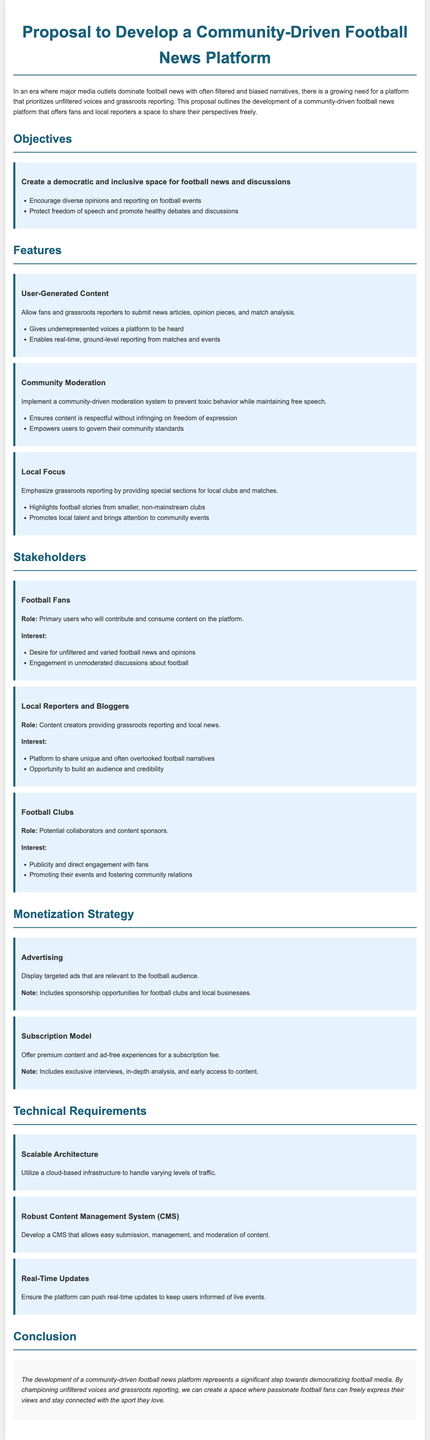What is the title of the proposal? The title is clearly stated at the beginning of the document.
Answer: Proposal to Develop a Community-Driven Football News Platform What is the primary role of football fans in this platform? The section on stakeholders defines the role of football fans in contributing and consuming content.
Answer: Primary users What feature emphasizes grassroots reporting? The proposal outlines features that support local clubs and events, indicating a focus on this aspect.
Answer: Local Focus What is one of the monetization strategies mentioned? The proposal discusses different monetization strategies for sustainability, specifically mentioning advertising.
Answer: Advertising How does the platform plan to prevent toxic behavior? The document explains the importance of moderation and community governance in the feature section.
Answer: Community Moderation What type of content will local reporters provide? The stakeholders section includes details about the type of reporting local reporters will focus on.
Answer: Grassroots reporting What is a key objective of the platform? Objectives are listed, including the creation of an inclusive space for discussions.
Answer: Create a democratic and inclusive space How will the platform ensure real-time updates? The technical requirements section specifies the need for capabilities that keep users informed in real-time.
Answer: Real-Time Updates What opportunity does the platform provide for local clubs? The stakeholders section mentions how the platform benefits local clubs as potential collaborators.
Answer: Publicity and direct engagement with fans 